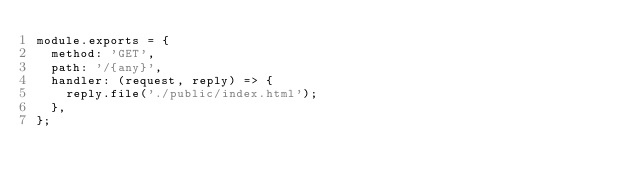Convert code to text. <code><loc_0><loc_0><loc_500><loc_500><_JavaScript_>module.exports = {
  method: 'GET',
  path: '/{any}',
  handler: (request, reply) => {
    reply.file('./public/index.html');
  },
};
</code> 